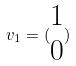<formula> <loc_0><loc_0><loc_500><loc_500>v _ { 1 } = ( \begin{matrix} 1 \\ 0 \end{matrix} )</formula> 